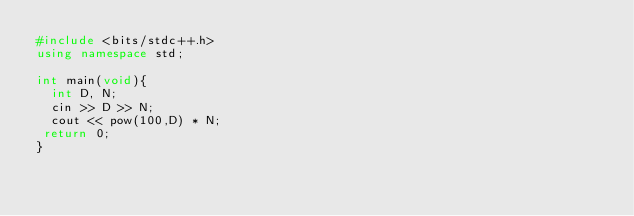Convert code to text. <code><loc_0><loc_0><loc_500><loc_500><_C++_>#include <bits/stdc++.h>
using namespace std;

int main(void){
  int D, N;
  cin >> D >> N;
  cout << pow(100,D) * N;
 return 0; 
}</code> 